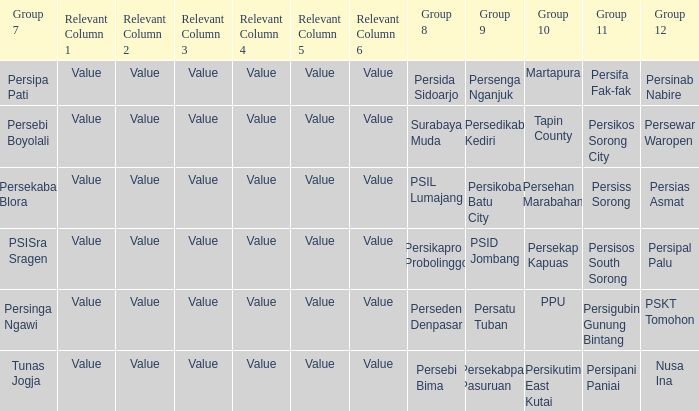Nusa Ina only played once while group 7 played. 1.0. 